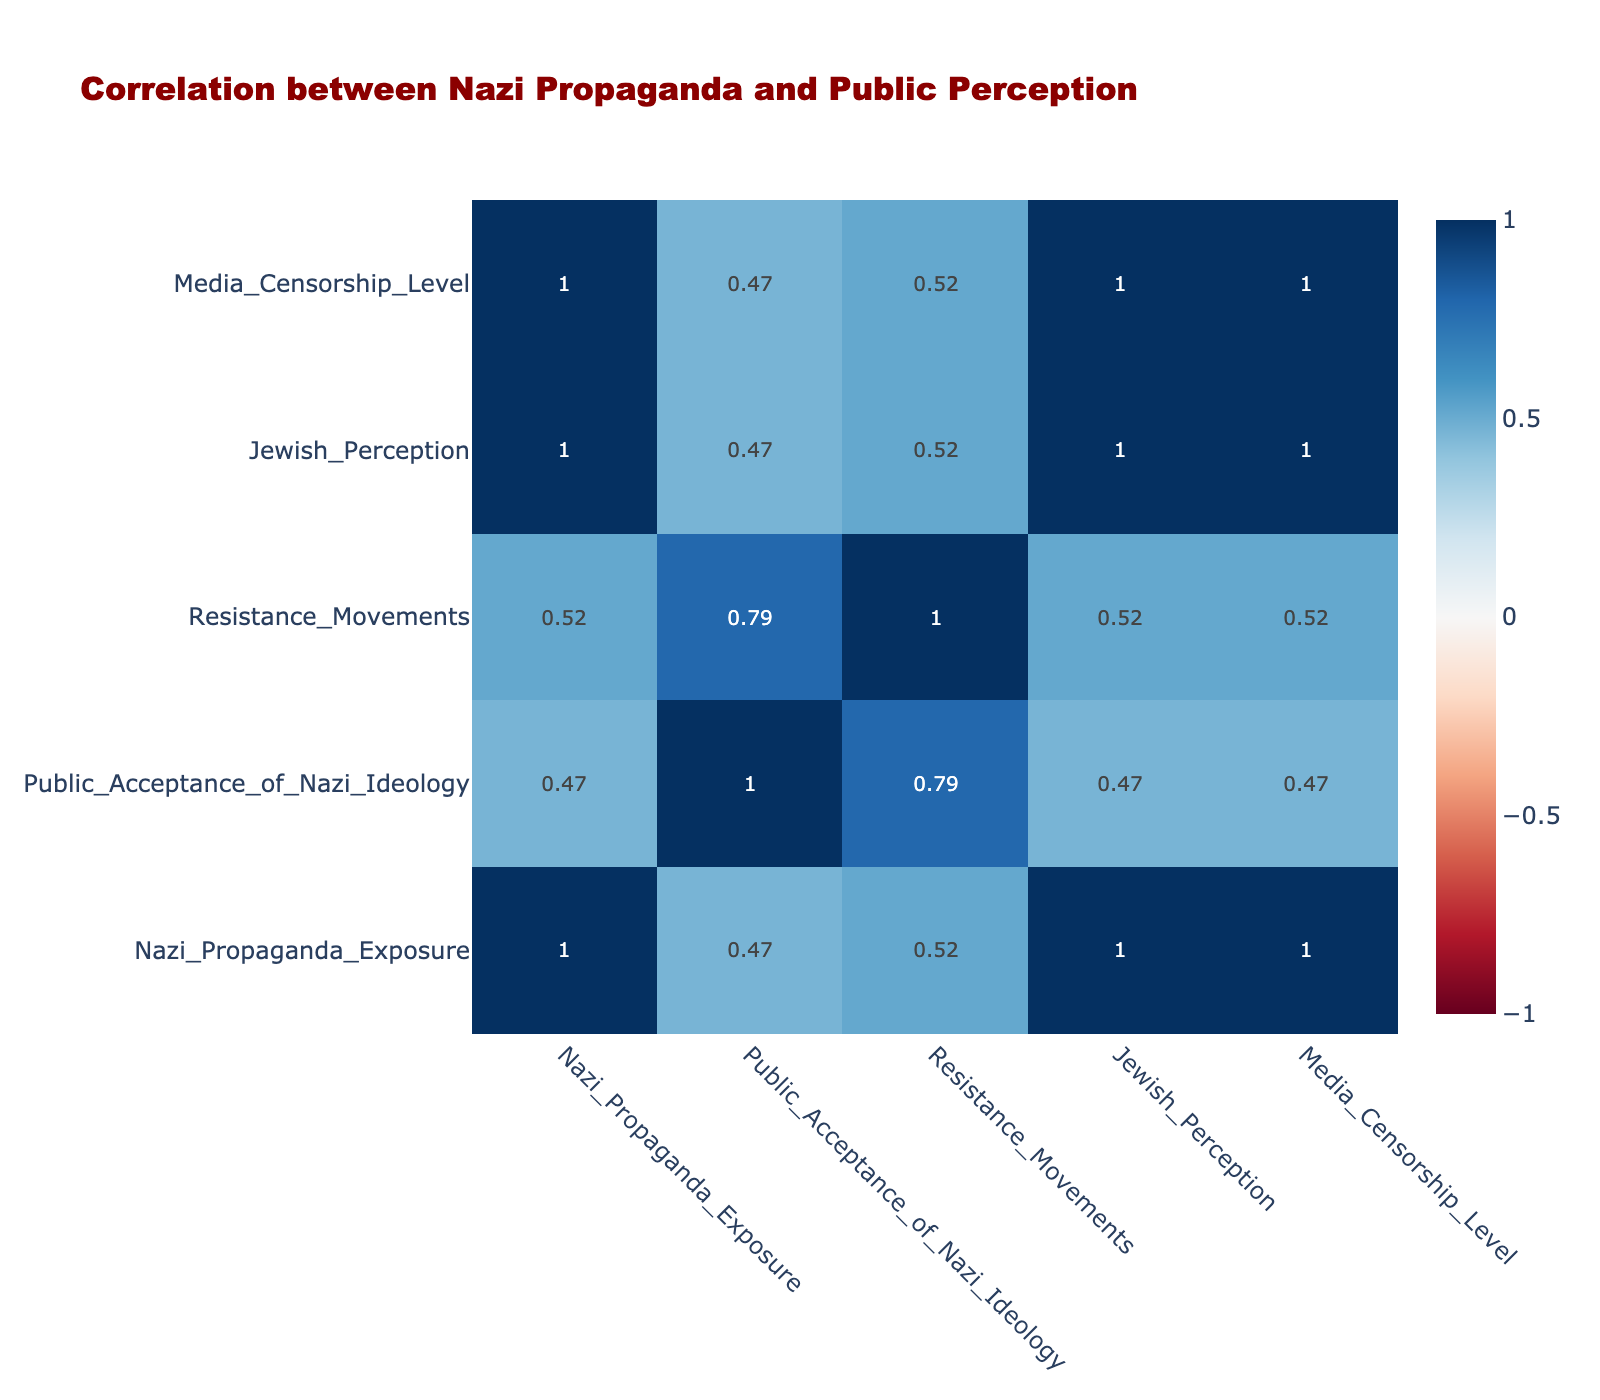What is the relationship between high exposure to Nazi propaganda and public acceptance of Nazi ideology? From the table, we can see that with high Nazi propaganda exposure, the public acceptance of Nazi ideology is also high. This indicates a strong positive correlation between these two variables.
Answer: High What is the level of media censorship when public acceptance of Nazi ideology is low? Looking at the table, when public acceptance of Nazi ideology is low, the levels of media censorship are also low. Therefore, there is a direct relationship where these levels coincide.
Answer: Low Is there any significant resistance movement when the public acceptance of Nazi ideology is high? The table shows that when public acceptance of Nazi ideology is high, the resistance movements are classified as low. Thus, there is no significant resistance when acceptance is high.
Answer: No What is the average perception of Jewish communities when exposure to Nazi propaganda is low? We see three instances in the table with low exposure to Nazi propaganda, where the Jewish perception is positive in all cases. Thus, the average perception can be calculated as positive (since all three entries are the same).
Answer: Positive What is the correlation between high levels of media censorship and resistance movements in alienated public acceptance? In the table, high media censorship is observed with low resistance movements. Specifically, with high media censorship, resistance movements consistently rank low when public acceptance is also high.
Answer: Low Does medium exposure to Nazi propaganda lead to a neutral Jewish perception? In the table, when the exposure to Nazi propaganda is medium, we find a neutral Jewish perception twice, indicating a relationship where medium propaganda exposure can lead to a neutral perception.
Answer: Yes What is the number of resistance movements when public acceptance of Nazi ideology is medium? With public acceptance of Nazi ideology categorized as medium, there are two rows in the table that indicate the resistance movements are moderate. This direct reading from the data shows a repeated response under these conditions.
Answer: Moderate Which condition leads to very low resistance movements based on Nazi propaganda exposure? The data illustrates that high exposure to Nazi propaganda results in very low resistance movements, suggesting that this specific exposure condition creates a strong correlation with lower resistance.
Answer: High exposure What is the difference in public acceptance levels between low and high exposure to Nazi propaganda? By analyzing the table, we see that public acceptance is low with low exposure and high with high exposure. The difference between high and low is two categories of acceptance (high - low).
Answer: Two categories 